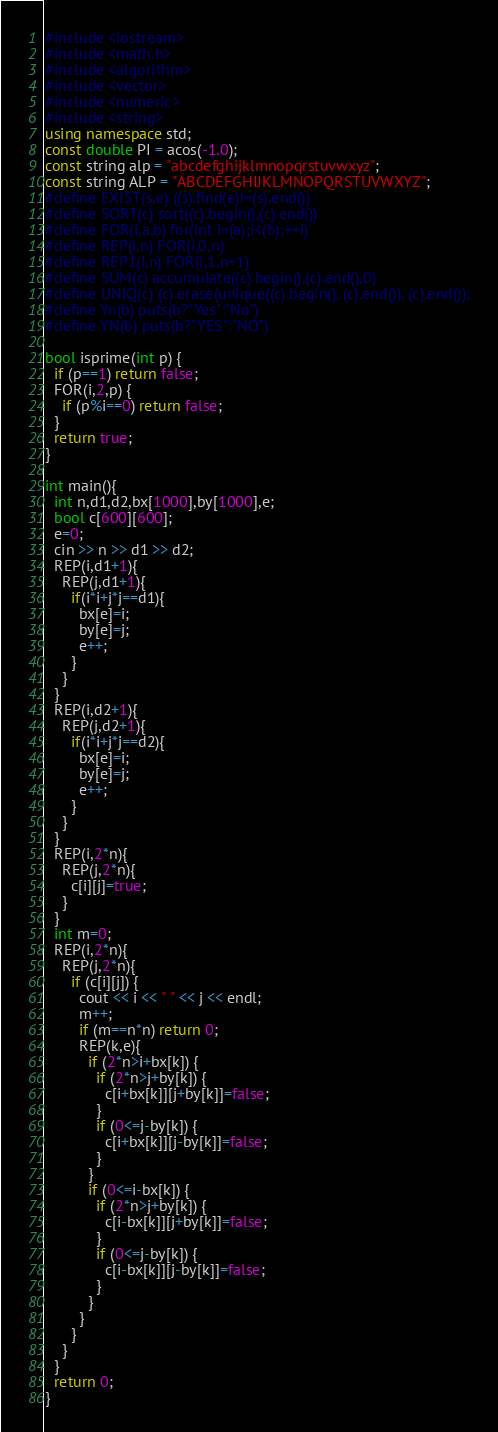<code> <loc_0><loc_0><loc_500><loc_500><_C++_>#include <iostream>
#include <math.h>
#include <algorithm>
#include <vector>
#include <numeric>
#include <string>
using namespace std;
const double PI = acos(-1.0);
const string alp = "abcdefghijklmnopqrstuvwxyz";
const string ALP = "ABCDEFGHIJKLMNOPQRSTUVWXYZ";
#define EXIST(s,e) ((s).find(e)!=(s).end())
#define SORT(c) sort((c).begin(),(c).end())
#define FOR(i,a,b) for(int i=(a);i<(b);++i)
#define REP(i,n) FOR(i,0,n)
#define REP1(i,n) FOR(i,1,n+1)
#define SUM(c) accumulate((c).begin(),(c).end(),0)
#define UNIQ(c) (c).erase(unique((c).begin(), (c).end()), (c).end());
#define Yn(b) puts(b?"Yes":"No")
#define YN(b) puts(b?"YES":"NO")
 
bool isprime(int p) {
  if (p==1) return false;
  FOR(i,2,p) {
    if (p%i==0) return false;
  }
  return true;
}

int main(){
  int n,d1,d2,bx[1000],by[1000],e;
  bool c[600][600];
  e=0;
  cin >> n >> d1 >> d2;
  REP(i,d1+1){
    REP(j,d1+1){
      if(i*i+j*j==d1){
        bx[e]=i;
        by[e]=j;
        e++;
      }
    }
  }
  REP(i,d2+1){
    REP(j,d2+1){
      if(i*i+j*j==d2){
        bx[e]=i;
        by[e]=j;
        e++;
      }
    }
  }
  REP(i,2*n){
    REP(j,2*n){
      c[i][j]=true;
    }
  }
  int m=0;
  REP(i,2*n){
    REP(j,2*n){
      if (c[i][j]) {
        cout << i << " " << j << endl;
        m++;
        if (m==n*n) return 0;
        REP(k,e){
          if (2*n>i+bx[k]) {
            if (2*n>j+by[k]) {
              c[i+bx[k]][j+by[k]]=false;
            }
            if (0<=j-by[k]) {
              c[i+bx[k]][j-by[k]]=false;
            }
          }
          if (0<=i-bx[k]) {
            if (2*n>j+by[k]) {
              c[i-bx[k]][j+by[k]]=false;
            }
            if (0<=j-by[k]) {
              c[i-bx[k]][j-by[k]]=false;
            }
          }
        }
      }
    }
  }
  return 0;
}</code> 